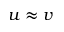<formula> <loc_0><loc_0><loc_500><loc_500>u \approx v</formula> 